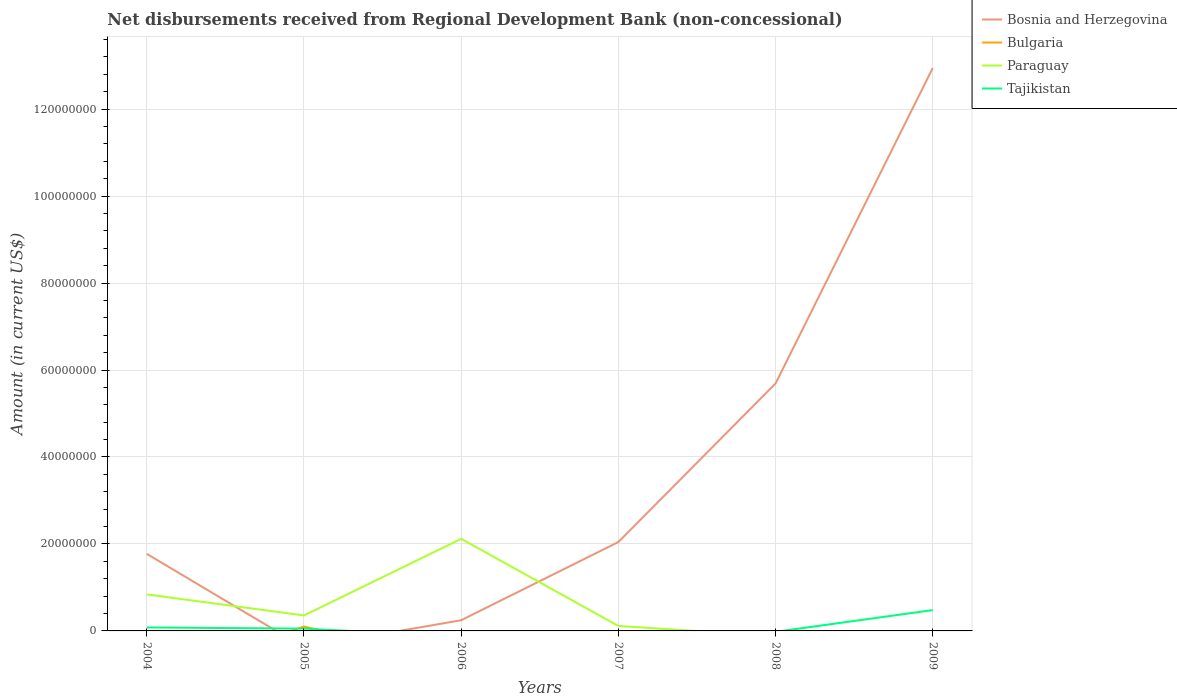How many different coloured lines are there?
Your response must be concise. 4. Does the line corresponding to Bosnia and Herzegovina intersect with the line corresponding to Tajikistan?
Provide a succinct answer. Yes. Is the number of lines equal to the number of legend labels?
Offer a very short reply. No. Across all years, what is the maximum amount of disbursements received from Regional Development Bank in Bulgaria?
Your answer should be very brief. 0. What is the total amount of disbursements received from Regional Development Bank in Paraguay in the graph?
Offer a terse response. -1.76e+07. What is the difference between the highest and the second highest amount of disbursements received from Regional Development Bank in Bosnia and Herzegovina?
Your answer should be compact. 1.29e+08. What is the difference between the highest and the lowest amount of disbursements received from Regional Development Bank in Paraguay?
Your answer should be compact. 2. How many years are there in the graph?
Keep it short and to the point. 6. Does the graph contain any zero values?
Keep it short and to the point. Yes. Does the graph contain grids?
Offer a terse response. Yes. How are the legend labels stacked?
Your answer should be very brief. Vertical. What is the title of the graph?
Offer a very short reply. Net disbursements received from Regional Development Bank (non-concessional). Does "Central African Republic" appear as one of the legend labels in the graph?
Your answer should be compact. No. What is the label or title of the X-axis?
Provide a short and direct response. Years. What is the Amount (in current US$) in Bosnia and Herzegovina in 2004?
Give a very brief answer. 1.77e+07. What is the Amount (in current US$) of Bulgaria in 2004?
Give a very brief answer. 0. What is the Amount (in current US$) in Paraguay in 2004?
Your response must be concise. 8.40e+06. What is the Amount (in current US$) of Tajikistan in 2004?
Make the answer very short. 7.99e+05. What is the Amount (in current US$) of Bulgaria in 2005?
Ensure brevity in your answer.  9.98e+05. What is the Amount (in current US$) of Paraguay in 2005?
Keep it short and to the point. 3.56e+06. What is the Amount (in current US$) of Tajikistan in 2005?
Offer a very short reply. 5.28e+05. What is the Amount (in current US$) of Bosnia and Herzegovina in 2006?
Your answer should be compact. 2.46e+06. What is the Amount (in current US$) in Bulgaria in 2006?
Keep it short and to the point. 0. What is the Amount (in current US$) of Paraguay in 2006?
Make the answer very short. 2.12e+07. What is the Amount (in current US$) of Bosnia and Herzegovina in 2007?
Provide a short and direct response. 2.04e+07. What is the Amount (in current US$) in Paraguay in 2007?
Your answer should be compact. 1.15e+06. What is the Amount (in current US$) of Tajikistan in 2007?
Offer a terse response. 0. What is the Amount (in current US$) in Bosnia and Herzegovina in 2008?
Ensure brevity in your answer.  5.69e+07. What is the Amount (in current US$) of Bosnia and Herzegovina in 2009?
Ensure brevity in your answer.  1.29e+08. What is the Amount (in current US$) in Paraguay in 2009?
Your answer should be compact. 0. What is the Amount (in current US$) in Tajikistan in 2009?
Make the answer very short. 4.79e+06. Across all years, what is the maximum Amount (in current US$) of Bosnia and Herzegovina?
Make the answer very short. 1.29e+08. Across all years, what is the maximum Amount (in current US$) in Bulgaria?
Keep it short and to the point. 9.98e+05. Across all years, what is the maximum Amount (in current US$) of Paraguay?
Ensure brevity in your answer.  2.12e+07. Across all years, what is the maximum Amount (in current US$) in Tajikistan?
Provide a succinct answer. 4.79e+06. Across all years, what is the minimum Amount (in current US$) in Bulgaria?
Provide a short and direct response. 0. What is the total Amount (in current US$) of Bosnia and Herzegovina in the graph?
Give a very brief answer. 2.27e+08. What is the total Amount (in current US$) in Bulgaria in the graph?
Offer a terse response. 9.98e+05. What is the total Amount (in current US$) of Paraguay in the graph?
Your response must be concise. 3.43e+07. What is the total Amount (in current US$) of Tajikistan in the graph?
Provide a short and direct response. 6.12e+06. What is the difference between the Amount (in current US$) in Paraguay in 2004 and that in 2005?
Make the answer very short. 4.84e+06. What is the difference between the Amount (in current US$) in Tajikistan in 2004 and that in 2005?
Provide a succinct answer. 2.71e+05. What is the difference between the Amount (in current US$) of Bosnia and Herzegovina in 2004 and that in 2006?
Make the answer very short. 1.53e+07. What is the difference between the Amount (in current US$) in Paraguay in 2004 and that in 2006?
Provide a short and direct response. -1.28e+07. What is the difference between the Amount (in current US$) in Bosnia and Herzegovina in 2004 and that in 2007?
Provide a short and direct response. -2.73e+06. What is the difference between the Amount (in current US$) of Paraguay in 2004 and that in 2007?
Keep it short and to the point. 7.25e+06. What is the difference between the Amount (in current US$) in Bosnia and Herzegovina in 2004 and that in 2008?
Your answer should be compact. -3.92e+07. What is the difference between the Amount (in current US$) of Bosnia and Herzegovina in 2004 and that in 2009?
Give a very brief answer. -1.12e+08. What is the difference between the Amount (in current US$) of Tajikistan in 2004 and that in 2009?
Provide a short and direct response. -3.99e+06. What is the difference between the Amount (in current US$) of Paraguay in 2005 and that in 2006?
Offer a terse response. -1.76e+07. What is the difference between the Amount (in current US$) in Paraguay in 2005 and that in 2007?
Provide a short and direct response. 2.41e+06. What is the difference between the Amount (in current US$) of Tajikistan in 2005 and that in 2009?
Offer a very short reply. -4.26e+06. What is the difference between the Amount (in current US$) of Bosnia and Herzegovina in 2006 and that in 2007?
Provide a succinct answer. -1.80e+07. What is the difference between the Amount (in current US$) of Paraguay in 2006 and that in 2007?
Your answer should be very brief. 2.00e+07. What is the difference between the Amount (in current US$) in Bosnia and Herzegovina in 2006 and that in 2008?
Your answer should be very brief. -5.45e+07. What is the difference between the Amount (in current US$) in Bosnia and Herzegovina in 2006 and that in 2009?
Offer a terse response. -1.27e+08. What is the difference between the Amount (in current US$) in Bosnia and Herzegovina in 2007 and that in 2008?
Keep it short and to the point. -3.65e+07. What is the difference between the Amount (in current US$) of Bosnia and Herzegovina in 2007 and that in 2009?
Give a very brief answer. -1.09e+08. What is the difference between the Amount (in current US$) in Bosnia and Herzegovina in 2008 and that in 2009?
Give a very brief answer. -7.26e+07. What is the difference between the Amount (in current US$) of Bosnia and Herzegovina in 2004 and the Amount (in current US$) of Bulgaria in 2005?
Your response must be concise. 1.67e+07. What is the difference between the Amount (in current US$) of Bosnia and Herzegovina in 2004 and the Amount (in current US$) of Paraguay in 2005?
Your answer should be compact. 1.42e+07. What is the difference between the Amount (in current US$) of Bosnia and Herzegovina in 2004 and the Amount (in current US$) of Tajikistan in 2005?
Your response must be concise. 1.72e+07. What is the difference between the Amount (in current US$) of Paraguay in 2004 and the Amount (in current US$) of Tajikistan in 2005?
Ensure brevity in your answer.  7.87e+06. What is the difference between the Amount (in current US$) of Bosnia and Herzegovina in 2004 and the Amount (in current US$) of Paraguay in 2006?
Make the answer very short. -3.46e+06. What is the difference between the Amount (in current US$) in Bosnia and Herzegovina in 2004 and the Amount (in current US$) in Paraguay in 2007?
Your answer should be compact. 1.66e+07. What is the difference between the Amount (in current US$) in Bosnia and Herzegovina in 2004 and the Amount (in current US$) in Tajikistan in 2009?
Your answer should be very brief. 1.29e+07. What is the difference between the Amount (in current US$) of Paraguay in 2004 and the Amount (in current US$) of Tajikistan in 2009?
Make the answer very short. 3.61e+06. What is the difference between the Amount (in current US$) of Bulgaria in 2005 and the Amount (in current US$) of Paraguay in 2006?
Your answer should be very brief. -2.02e+07. What is the difference between the Amount (in current US$) in Bulgaria in 2005 and the Amount (in current US$) in Paraguay in 2007?
Keep it short and to the point. -1.52e+05. What is the difference between the Amount (in current US$) of Bulgaria in 2005 and the Amount (in current US$) of Tajikistan in 2009?
Make the answer very short. -3.79e+06. What is the difference between the Amount (in current US$) in Paraguay in 2005 and the Amount (in current US$) in Tajikistan in 2009?
Keep it short and to the point. -1.23e+06. What is the difference between the Amount (in current US$) of Bosnia and Herzegovina in 2006 and the Amount (in current US$) of Paraguay in 2007?
Provide a succinct answer. 1.31e+06. What is the difference between the Amount (in current US$) of Bosnia and Herzegovina in 2006 and the Amount (in current US$) of Tajikistan in 2009?
Your answer should be very brief. -2.33e+06. What is the difference between the Amount (in current US$) of Paraguay in 2006 and the Amount (in current US$) of Tajikistan in 2009?
Your answer should be very brief. 1.64e+07. What is the difference between the Amount (in current US$) in Bosnia and Herzegovina in 2007 and the Amount (in current US$) in Tajikistan in 2009?
Your answer should be compact. 1.57e+07. What is the difference between the Amount (in current US$) of Paraguay in 2007 and the Amount (in current US$) of Tajikistan in 2009?
Your answer should be very brief. -3.64e+06. What is the difference between the Amount (in current US$) in Bosnia and Herzegovina in 2008 and the Amount (in current US$) in Tajikistan in 2009?
Provide a short and direct response. 5.21e+07. What is the average Amount (in current US$) in Bosnia and Herzegovina per year?
Keep it short and to the point. 3.78e+07. What is the average Amount (in current US$) of Bulgaria per year?
Make the answer very short. 1.66e+05. What is the average Amount (in current US$) in Paraguay per year?
Offer a terse response. 5.71e+06. What is the average Amount (in current US$) in Tajikistan per year?
Your response must be concise. 1.02e+06. In the year 2004, what is the difference between the Amount (in current US$) in Bosnia and Herzegovina and Amount (in current US$) in Paraguay?
Provide a succinct answer. 9.32e+06. In the year 2004, what is the difference between the Amount (in current US$) of Bosnia and Herzegovina and Amount (in current US$) of Tajikistan?
Provide a short and direct response. 1.69e+07. In the year 2004, what is the difference between the Amount (in current US$) in Paraguay and Amount (in current US$) in Tajikistan?
Offer a very short reply. 7.60e+06. In the year 2005, what is the difference between the Amount (in current US$) in Bulgaria and Amount (in current US$) in Paraguay?
Your response must be concise. -2.56e+06. In the year 2005, what is the difference between the Amount (in current US$) in Bulgaria and Amount (in current US$) in Tajikistan?
Offer a very short reply. 4.70e+05. In the year 2005, what is the difference between the Amount (in current US$) of Paraguay and Amount (in current US$) of Tajikistan?
Provide a succinct answer. 3.03e+06. In the year 2006, what is the difference between the Amount (in current US$) in Bosnia and Herzegovina and Amount (in current US$) in Paraguay?
Keep it short and to the point. -1.87e+07. In the year 2007, what is the difference between the Amount (in current US$) of Bosnia and Herzegovina and Amount (in current US$) of Paraguay?
Make the answer very short. 1.93e+07. In the year 2009, what is the difference between the Amount (in current US$) in Bosnia and Herzegovina and Amount (in current US$) in Tajikistan?
Give a very brief answer. 1.25e+08. What is the ratio of the Amount (in current US$) of Paraguay in 2004 to that in 2005?
Provide a short and direct response. 2.36. What is the ratio of the Amount (in current US$) in Tajikistan in 2004 to that in 2005?
Your answer should be very brief. 1.51. What is the ratio of the Amount (in current US$) in Bosnia and Herzegovina in 2004 to that in 2006?
Your answer should be very brief. 7.21. What is the ratio of the Amount (in current US$) in Paraguay in 2004 to that in 2006?
Give a very brief answer. 0.4. What is the ratio of the Amount (in current US$) in Bosnia and Herzegovina in 2004 to that in 2007?
Provide a short and direct response. 0.87. What is the ratio of the Amount (in current US$) in Paraguay in 2004 to that in 2007?
Give a very brief answer. 7.3. What is the ratio of the Amount (in current US$) in Bosnia and Herzegovina in 2004 to that in 2008?
Your response must be concise. 0.31. What is the ratio of the Amount (in current US$) in Bosnia and Herzegovina in 2004 to that in 2009?
Your answer should be compact. 0.14. What is the ratio of the Amount (in current US$) of Tajikistan in 2004 to that in 2009?
Provide a short and direct response. 0.17. What is the ratio of the Amount (in current US$) of Paraguay in 2005 to that in 2006?
Give a very brief answer. 0.17. What is the ratio of the Amount (in current US$) of Paraguay in 2005 to that in 2007?
Ensure brevity in your answer.  3.09. What is the ratio of the Amount (in current US$) in Tajikistan in 2005 to that in 2009?
Provide a succinct answer. 0.11. What is the ratio of the Amount (in current US$) of Bosnia and Herzegovina in 2006 to that in 2007?
Provide a short and direct response. 0.12. What is the ratio of the Amount (in current US$) in Paraguay in 2006 to that in 2007?
Provide a short and direct response. 18.41. What is the ratio of the Amount (in current US$) in Bosnia and Herzegovina in 2006 to that in 2008?
Keep it short and to the point. 0.04. What is the ratio of the Amount (in current US$) in Bosnia and Herzegovina in 2006 to that in 2009?
Offer a very short reply. 0.02. What is the ratio of the Amount (in current US$) in Bosnia and Herzegovina in 2007 to that in 2008?
Your response must be concise. 0.36. What is the ratio of the Amount (in current US$) of Bosnia and Herzegovina in 2007 to that in 2009?
Ensure brevity in your answer.  0.16. What is the ratio of the Amount (in current US$) in Bosnia and Herzegovina in 2008 to that in 2009?
Offer a very short reply. 0.44. What is the difference between the highest and the second highest Amount (in current US$) of Bosnia and Herzegovina?
Offer a very short reply. 7.26e+07. What is the difference between the highest and the second highest Amount (in current US$) in Paraguay?
Give a very brief answer. 1.28e+07. What is the difference between the highest and the second highest Amount (in current US$) in Tajikistan?
Your answer should be compact. 3.99e+06. What is the difference between the highest and the lowest Amount (in current US$) of Bosnia and Herzegovina?
Make the answer very short. 1.29e+08. What is the difference between the highest and the lowest Amount (in current US$) in Bulgaria?
Provide a succinct answer. 9.98e+05. What is the difference between the highest and the lowest Amount (in current US$) in Paraguay?
Your answer should be compact. 2.12e+07. What is the difference between the highest and the lowest Amount (in current US$) of Tajikistan?
Ensure brevity in your answer.  4.79e+06. 